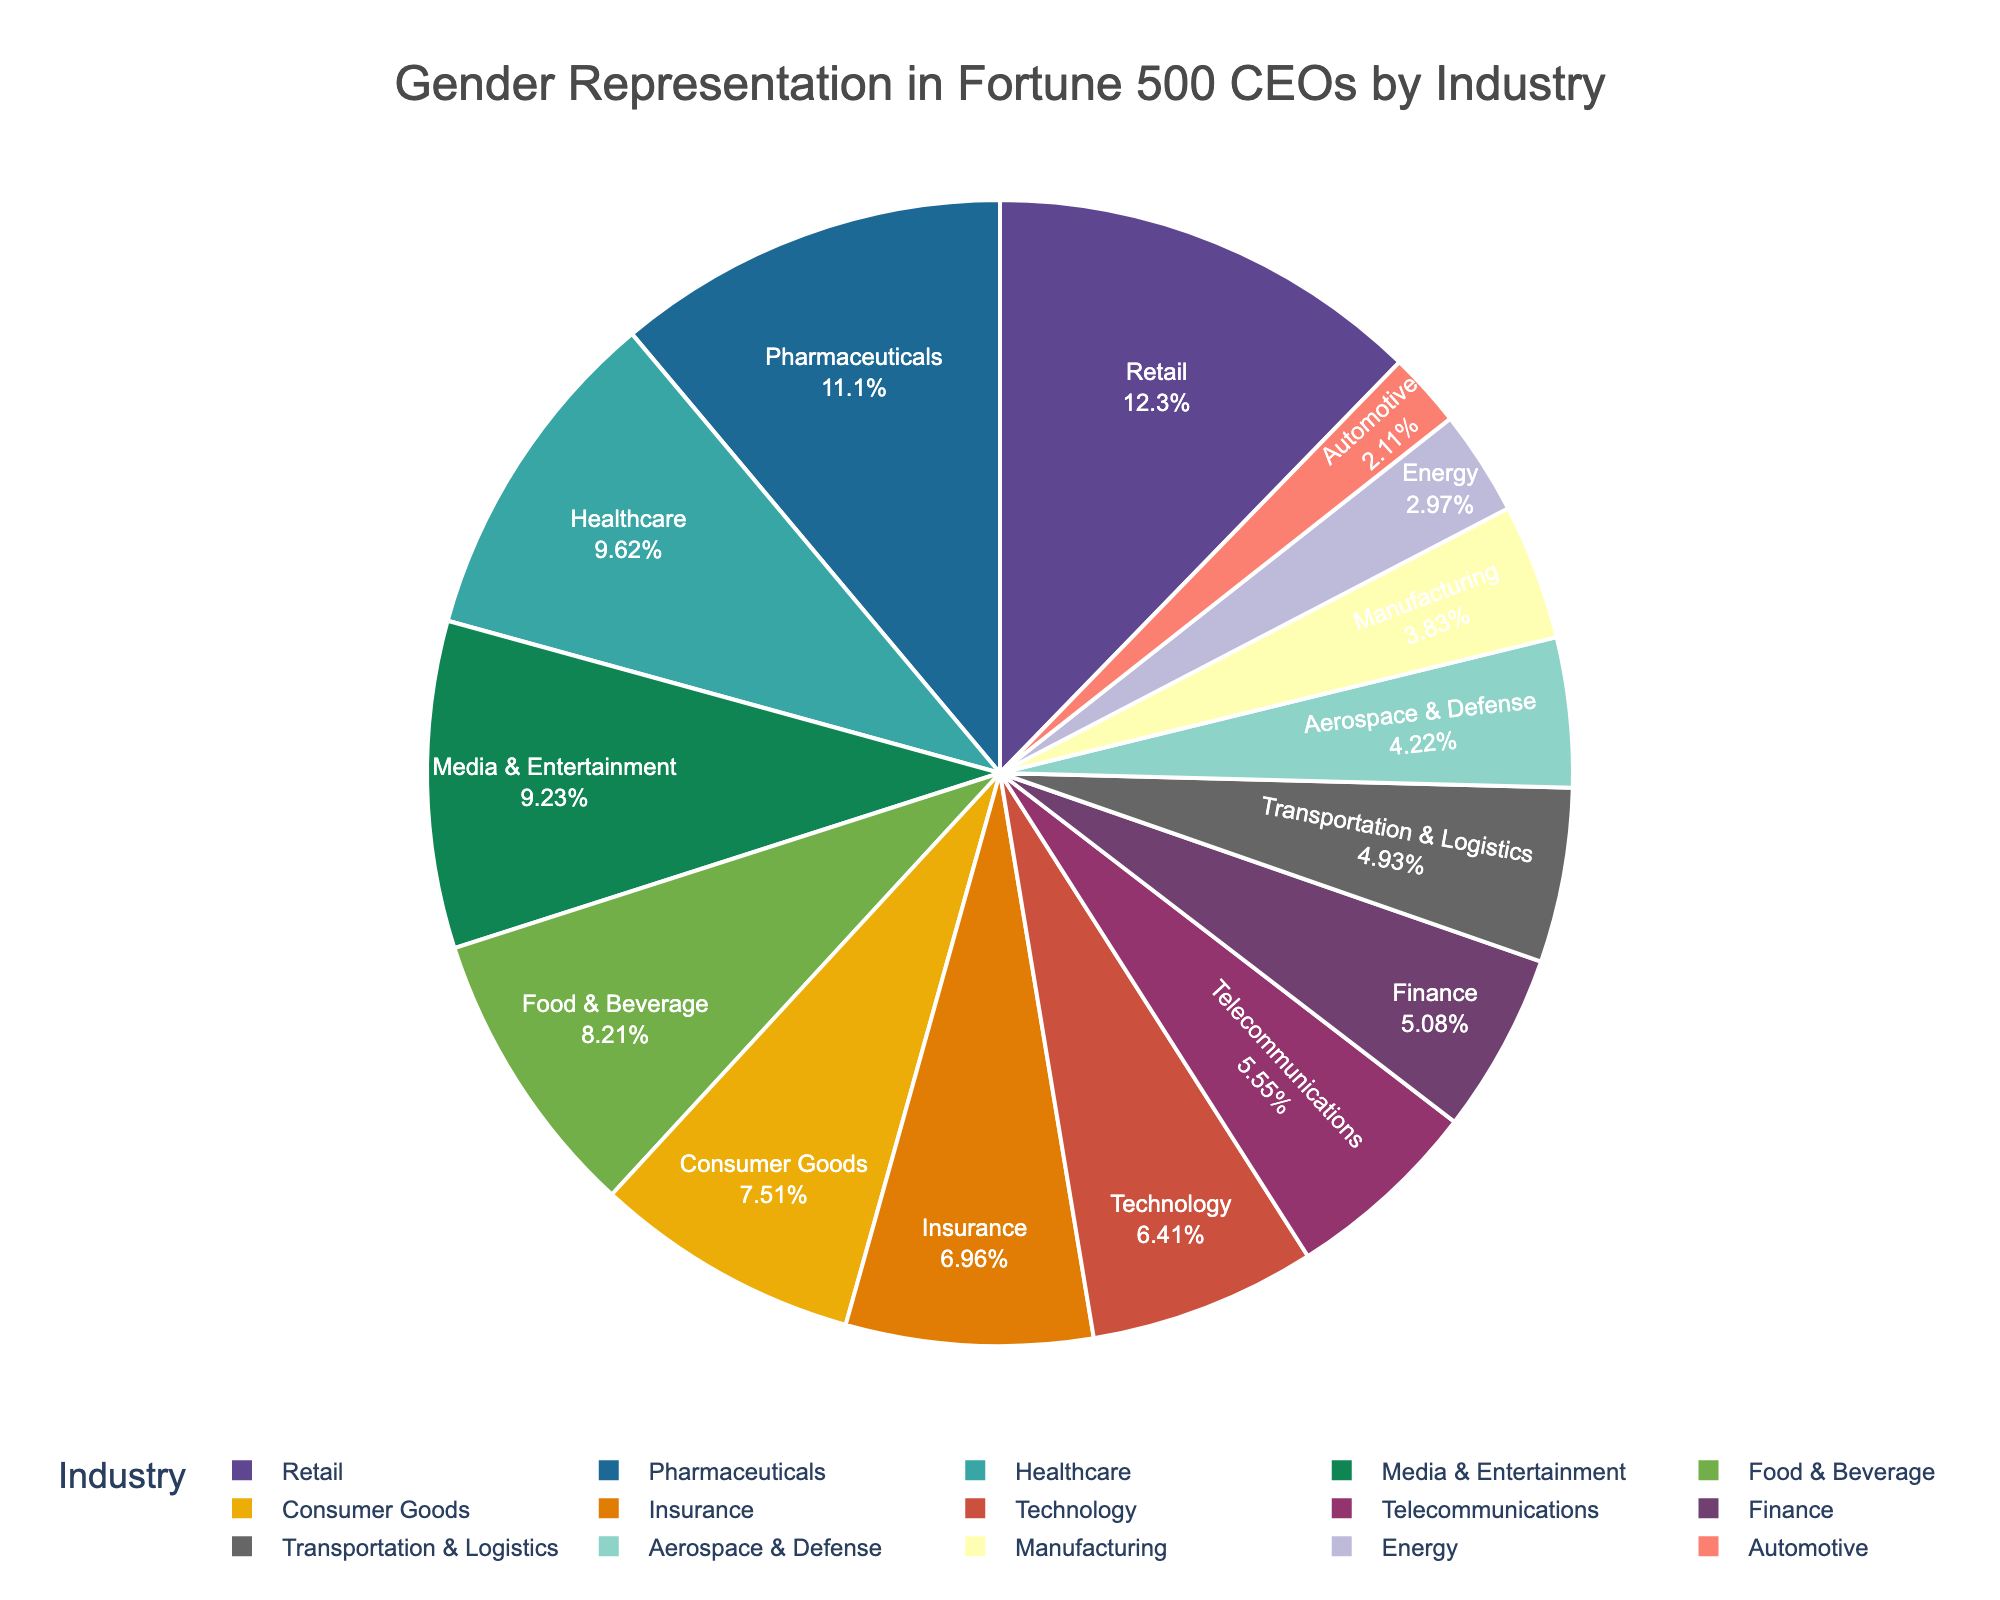Which industry has the highest percentage of female CEOs? To determine the industry with the highest percentage of female CEOs, scan the values and identify the maximum. Retail has the highest percentage at 15.7%.
Answer: Retail Which industry has the lowest representation of female CEOs? Look for the smallest percentage among the industries listed. Automotive has the smallest percentage at 2.7%.
Answer: Automotive How many industries have more than 10% female CEOs? Count the number of industries where the percentage of female CEOs exceeds 10%. Healthcare, Retail, Media & Entertainment, Pharmaceuticals, and Food & Beverage meet this criterion.
Answer: 5 Is the percentage of female CEOs in Technology higher than in Finance? Compare the percentages of Technology and Finance. Technology has 8.2%, while Finance has 6.5%. Since 8.2% is greater than 6.5%, Technology has a higher percentage.
Answer: Yes What's the combined percentage of female CEOs in Energy and Automotive? Add the percentages for Energy and Automotive. Energy has 3.8% and Automotive has 2.7%, which totals 6.5%.
Answer: 6.5% Which industry has a higher percentage of female CEOs: Pharmaceuticals or Media & Entertainment? Compare the percentages of Pharmaceuticals and Media & Entertainment. Pharmaceuticals has 14.2% and Media & Entertainment has 11.8%. Since 14.2% is greater than 11.8%, Pharmaceuticals has a higher percentage.
Answer: Pharmaceuticals What's the average percentage of female CEOs across Technology, Finance, and Telecommunications? Add the percentages of Technology (8.2%), Finance (6.5%), and Telecommunications (7.1%) and divide by 3. The sum is 21.8%, and the average is 21.8% / 3 = 7.27%.
Answer: 7.27% Which sector has a larger share of female CEOs, Food & Beverage or Consumer Goods? Compare the percentages of Food & Beverage and Consumer Goods. Food & Beverage has 10.5%, while Consumer Goods has 9.6%. Since 10.5% is greater than 9.6%, Food & Beverage has a larger share.
Answer: Food & Beverage Are there more female CEOs in Healthcare or Insurance industries? Compare the percentages of Healthcare and Insurance. Healthcare has 12.3%, while Insurance has 8.9%. Since 12.3% is greater than 8.9%, Healthcare has more female CEOs.
Answer: Healthcare 